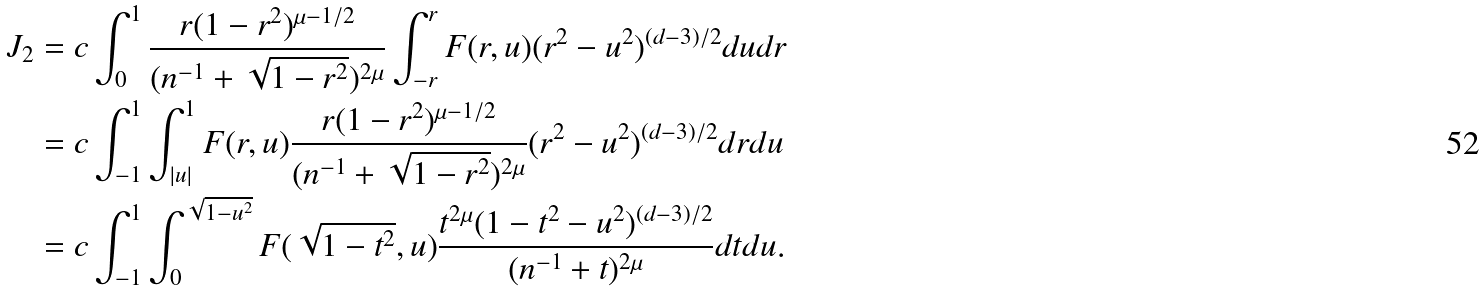Convert formula to latex. <formula><loc_0><loc_0><loc_500><loc_500>J _ { 2 } & = c \int _ { 0 } ^ { 1 } \frac { r ( 1 - r ^ { 2 } ) ^ { \mu - 1 / 2 } } { ( n ^ { - 1 } + \sqrt { 1 - r ^ { 2 } } ) ^ { 2 \mu } } \int _ { - r } ^ { r } F ( r , u ) ( r ^ { 2 } - u ^ { 2 } ) ^ { ( d - 3 ) / 2 } d u d r \\ & = c \int _ { - 1 } ^ { 1 } \int _ { | u | } ^ { 1 } F ( r , u ) \frac { r ( 1 - r ^ { 2 } ) ^ { \mu - 1 / 2 } } { ( n ^ { - 1 } + \sqrt { 1 - r ^ { 2 } } ) ^ { 2 \mu } } ( r ^ { 2 } - u ^ { 2 } ) ^ { ( d - 3 ) / 2 } d r d u \\ & = c \int _ { - 1 } ^ { 1 } \int _ { 0 } ^ { \sqrt { 1 - u ^ { 2 } } } F ( \sqrt { 1 - t ^ { 2 } } , u ) \frac { t ^ { 2 \mu } ( 1 - t ^ { 2 } - u ^ { 2 } ) ^ { ( d - 3 ) / 2 } } { ( n ^ { - 1 } + t ) ^ { 2 \mu } } d t d u .</formula> 